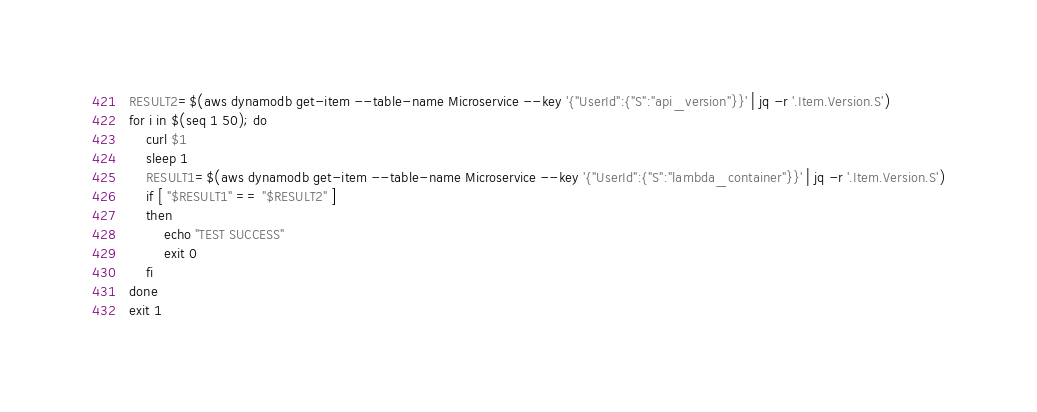<code> <loc_0><loc_0><loc_500><loc_500><_Bash_>RESULT2=$(aws dynamodb get-item --table-name Microservice --key '{"UserId":{"S":"api_version"}}' | jq -r '.Item.Version.S')
for i in $(seq 1 50); do
    curl $1
    sleep 1
    RESULT1=$(aws dynamodb get-item --table-name Microservice --key '{"UserId":{"S":"lambda_container"}}' | jq -r '.Item.Version.S')
    if [ "$RESULT1" == "$RESULT2" ]
    then
        echo "TEST SUCCESS"
        exit 0
    fi
done
exit 1</code> 